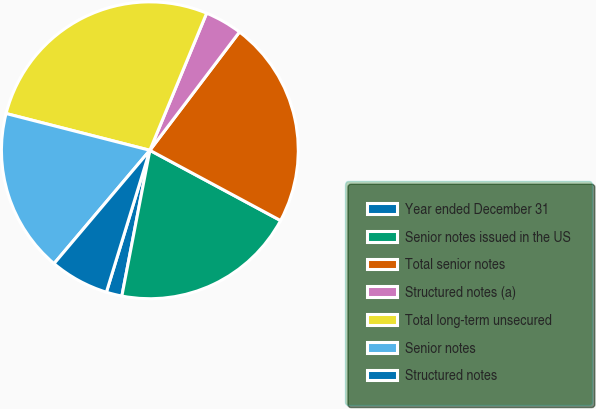<chart> <loc_0><loc_0><loc_500><loc_500><pie_chart><fcel>Year ended December 31<fcel>Senior notes issued in the US<fcel>Total senior notes<fcel>Structured notes (a)<fcel>Total long-term unsecured<fcel>Senior notes<fcel>Structured notes<nl><fcel>1.71%<fcel>20.17%<fcel>22.53%<fcel>4.07%<fcel>27.26%<fcel>17.81%<fcel>6.44%<nl></chart> 